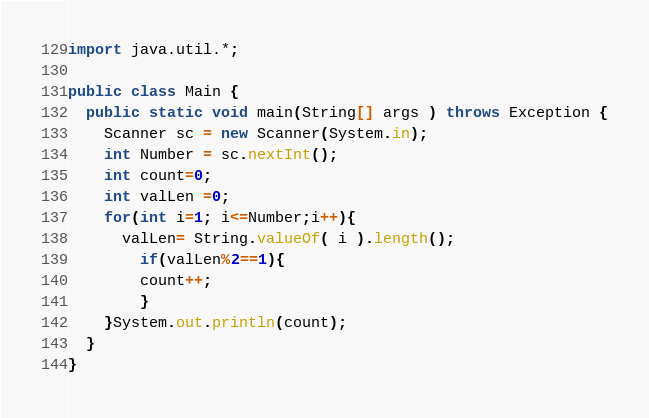Convert code to text. <code><loc_0><loc_0><loc_500><loc_500><_Java_>import java.util.*;

public class Main {
  public static void main(String[] args ) throws Exception {
    Scanner sc = new Scanner(System.in);
    int Number = sc.nextInt();
    int count=0;
    int valLen =0;
    for(int i=1; i<=Number;i++){
      valLen= String.valueOf( i ).length();
    	if(valLen%2==1){
        count++;
        }
    }System.out.println(count);
  }
}

</code> 